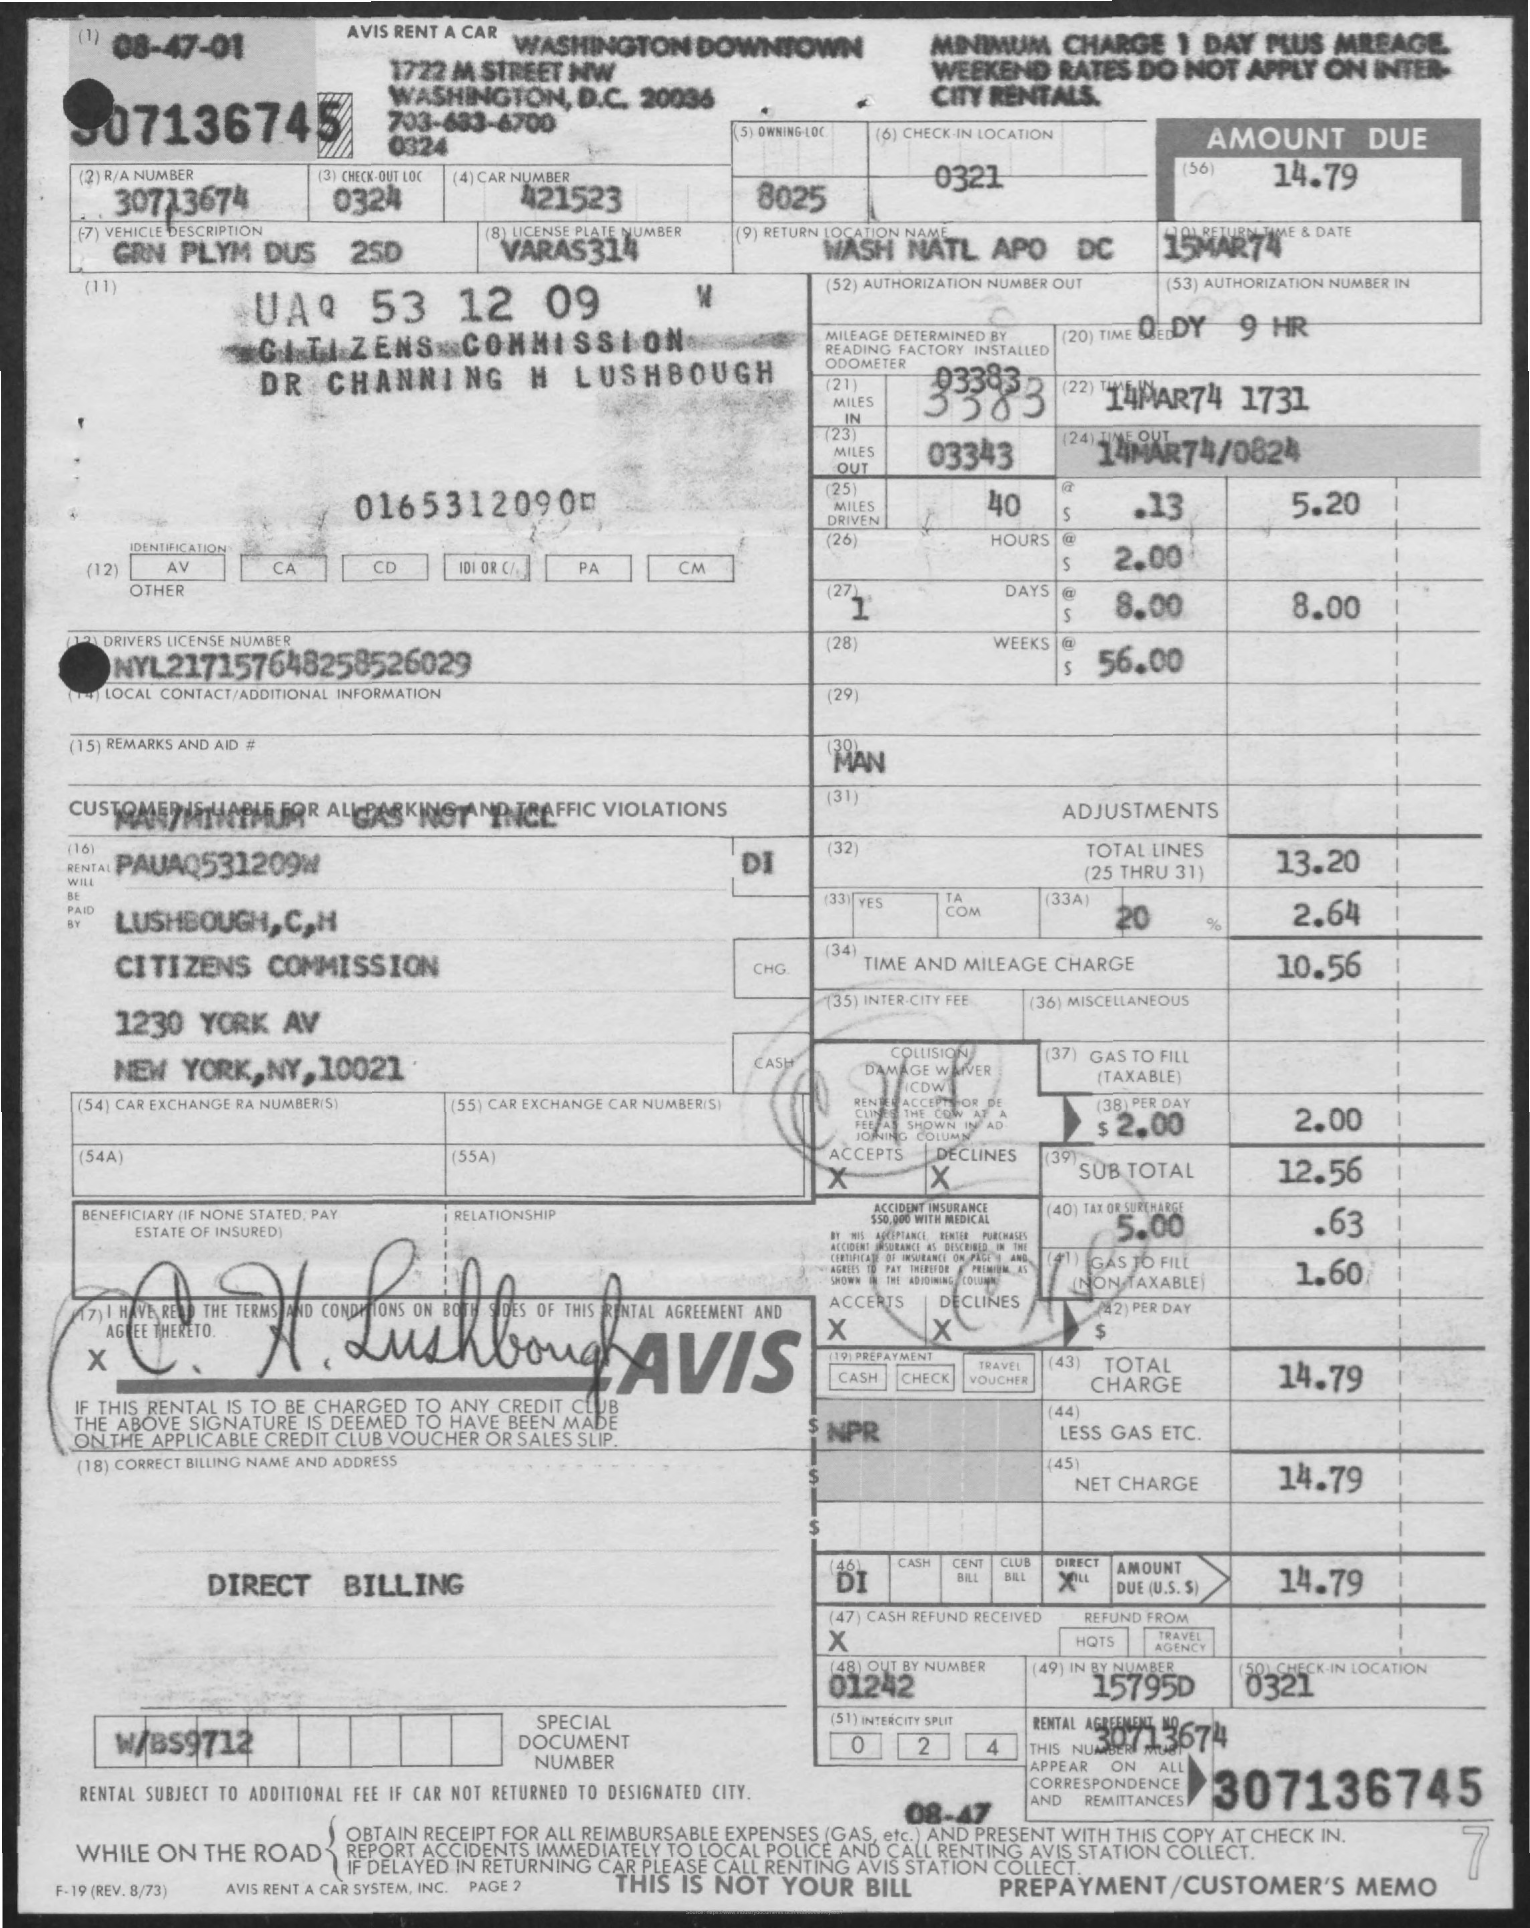Outline some significant characteristics in this image. The return location name is WASH NATL APO DC. The vehicle in question is described as a GRN PLYM DUS 2SD. The license plate number is VARAS314. The driver's license number is NYL217157648258526029. The check-out location is 0324. 